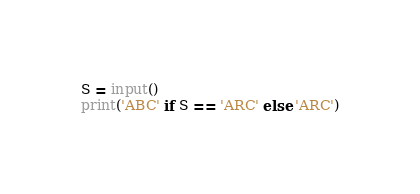<code> <loc_0><loc_0><loc_500><loc_500><_Python_>S = input()
print('ABC' if S == 'ARC' else 'ARC')</code> 